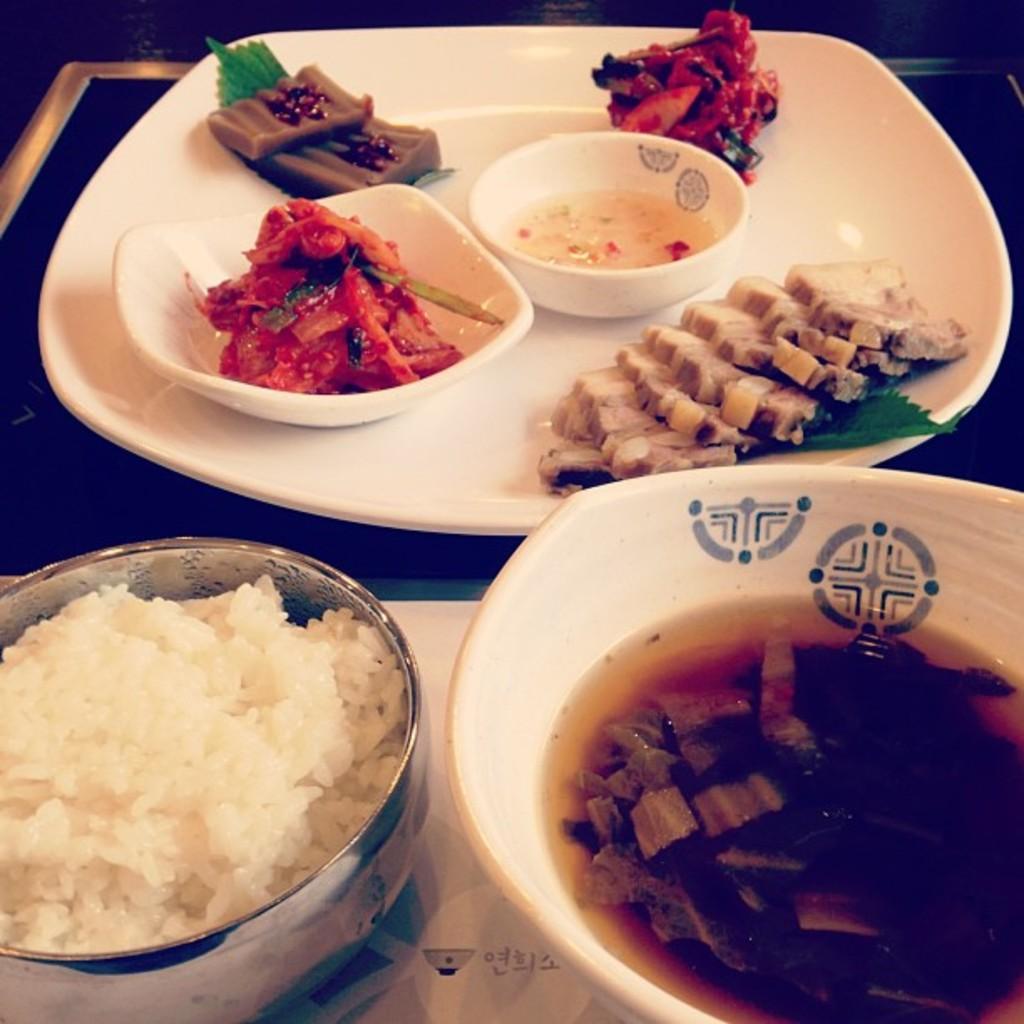How would you summarize this image in a sentence or two? Bottom of the image there is a table, on the table there are some plates and bowls and cups and food and rice. 